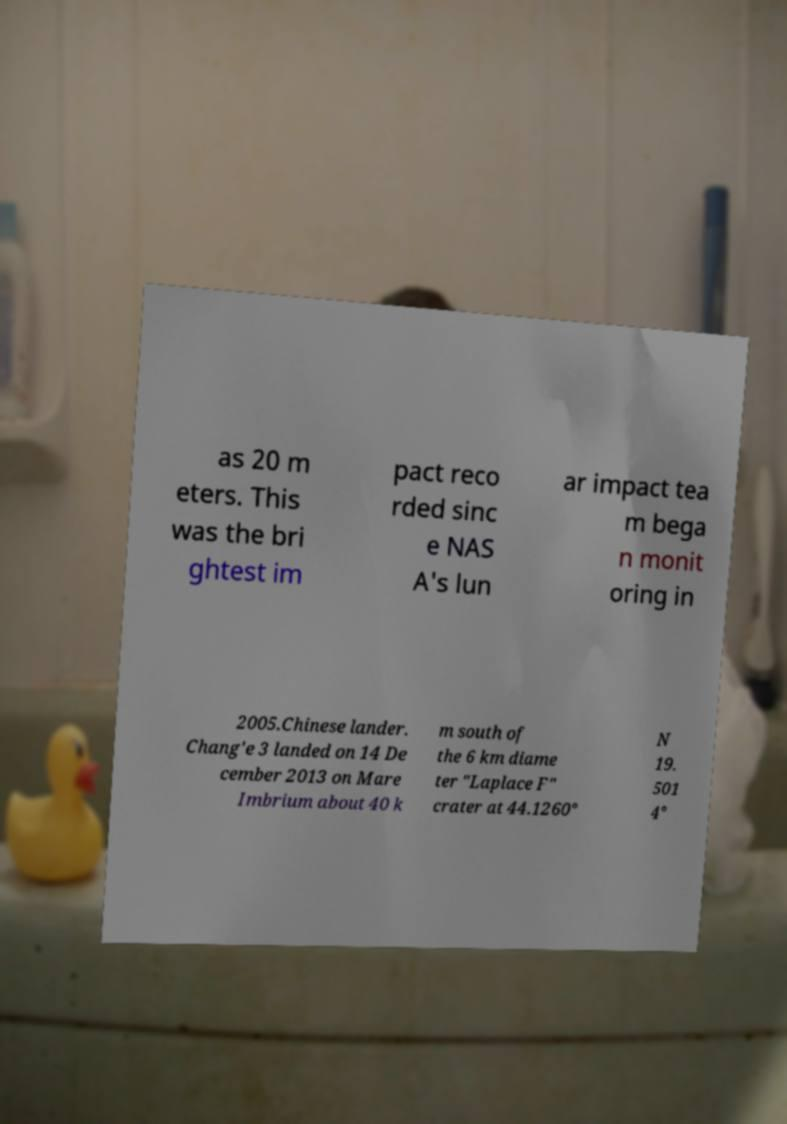Could you extract and type out the text from this image? as 20 m eters. This was the bri ghtest im pact reco rded sinc e NAS A's lun ar impact tea m bega n monit oring in 2005.Chinese lander. Chang'e 3 landed on 14 De cember 2013 on Mare Imbrium about 40 k m south of the 6 km diame ter "Laplace F" crater at 44.1260° N 19. 501 4° 